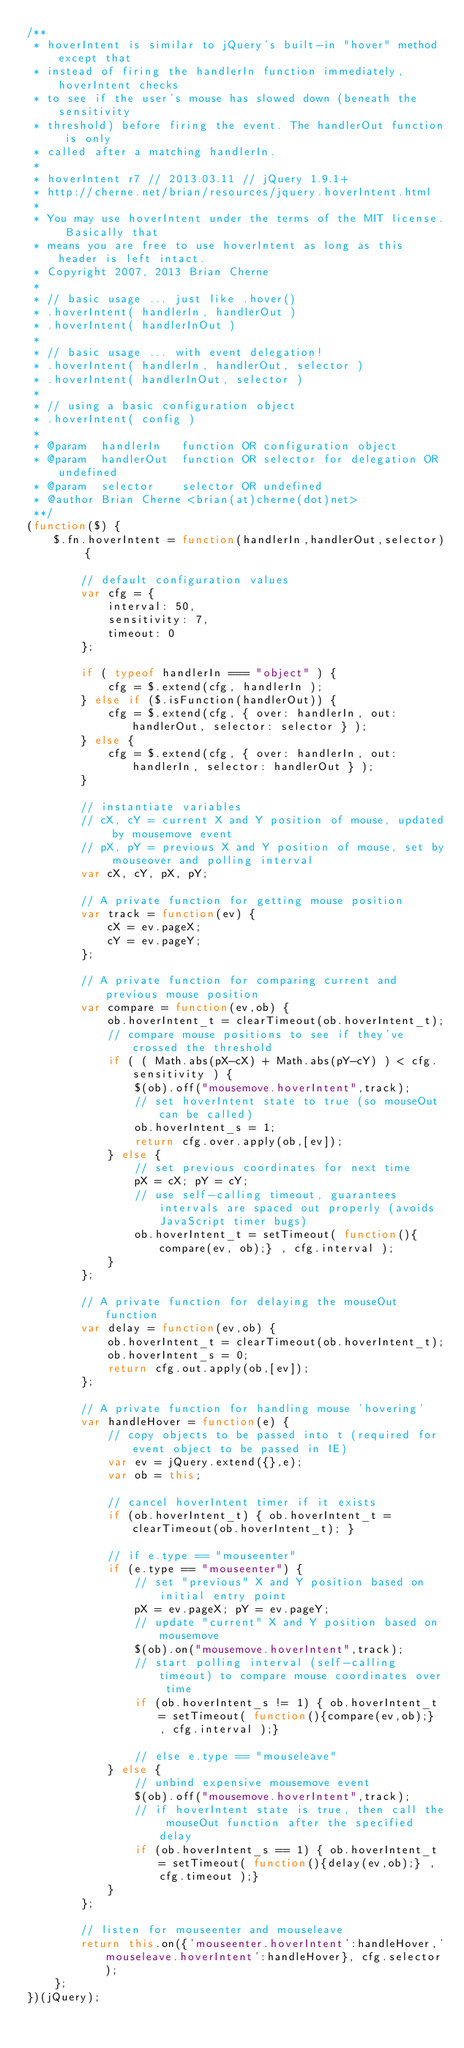<code> <loc_0><loc_0><loc_500><loc_500><_JavaScript_>/**
 * hoverIntent is similar to jQuery's built-in "hover" method except that
 * instead of firing the handlerIn function immediately, hoverIntent checks
 * to see if the user's mouse has slowed down (beneath the sensitivity
 * threshold) before firing the event. The handlerOut function is only
 * called after a matching handlerIn.
 *
 * hoverIntent r7 // 2013.03.11 // jQuery 1.9.1+
 * http://cherne.net/brian/resources/jquery.hoverIntent.html
 *
 * You may use hoverIntent under the terms of the MIT license. Basically that
 * means you are free to use hoverIntent as long as this header is left intact.
 * Copyright 2007, 2013 Brian Cherne
 *
 * // basic usage ... just like .hover()
 * .hoverIntent( handlerIn, handlerOut )
 * .hoverIntent( handlerInOut )
 *
 * // basic usage ... with event delegation!
 * .hoverIntent( handlerIn, handlerOut, selector )
 * .hoverIntent( handlerInOut, selector )
 *
 * // using a basic configuration object
 * .hoverIntent( config )
 *
 * @param  handlerIn   function OR configuration object
 * @param  handlerOut  function OR selector for delegation OR undefined
 * @param  selector    selector OR undefined
 * @author Brian Cherne <brian(at)cherne(dot)net>
 **/
(function($) {
    $.fn.hoverIntent = function(handlerIn,handlerOut,selector) {

        // default configuration values
        var cfg = {
            interval: 50,
            sensitivity: 7,
            timeout: 0
        };

        if ( typeof handlerIn === "object" ) {
            cfg = $.extend(cfg, handlerIn );
        } else if ($.isFunction(handlerOut)) {
            cfg = $.extend(cfg, { over: handlerIn, out: handlerOut, selector: selector } );
        } else {
            cfg = $.extend(cfg, { over: handlerIn, out: handlerIn, selector: handlerOut } );
        }

        // instantiate variables
        // cX, cY = current X and Y position of mouse, updated by mousemove event
        // pX, pY = previous X and Y position of mouse, set by mouseover and polling interval
        var cX, cY, pX, pY;

        // A private function for getting mouse position
        var track = function(ev) {
            cX = ev.pageX;
            cY = ev.pageY;
        };

        // A private function for comparing current and previous mouse position
        var compare = function(ev,ob) {
            ob.hoverIntent_t = clearTimeout(ob.hoverIntent_t);
            // compare mouse positions to see if they've crossed the threshold
            if ( ( Math.abs(pX-cX) + Math.abs(pY-cY) ) < cfg.sensitivity ) {
                $(ob).off("mousemove.hoverIntent",track);
                // set hoverIntent state to true (so mouseOut can be called)
                ob.hoverIntent_s = 1;
                return cfg.over.apply(ob,[ev]);
            } else {
                // set previous coordinates for next time
                pX = cX; pY = cY;
                // use self-calling timeout, guarantees intervals are spaced out properly (avoids JavaScript timer bugs)
                ob.hoverIntent_t = setTimeout( function(){compare(ev, ob);} , cfg.interval );
            }
        };

        // A private function for delaying the mouseOut function
        var delay = function(ev,ob) {
            ob.hoverIntent_t = clearTimeout(ob.hoverIntent_t);
            ob.hoverIntent_s = 0;
            return cfg.out.apply(ob,[ev]);
        };

        // A private function for handling mouse 'hovering'
        var handleHover = function(e) {
            // copy objects to be passed into t (required for event object to be passed in IE)
            var ev = jQuery.extend({},e);
            var ob = this;

            // cancel hoverIntent timer if it exists
            if (ob.hoverIntent_t) { ob.hoverIntent_t = clearTimeout(ob.hoverIntent_t); }

            // if e.type == "mouseenter"
            if (e.type == "mouseenter") {
                // set "previous" X and Y position based on initial entry point
                pX = ev.pageX; pY = ev.pageY;
                // update "current" X and Y position based on mousemove
                $(ob).on("mousemove.hoverIntent",track);
                // start polling interval (self-calling timeout) to compare mouse coordinates over time
                if (ob.hoverIntent_s != 1) { ob.hoverIntent_t = setTimeout( function(){compare(ev,ob);} , cfg.interval );}

                // else e.type == "mouseleave"
            } else {
                // unbind expensive mousemove event
                $(ob).off("mousemove.hoverIntent",track);
                // if hoverIntent state is true, then call the mouseOut function after the specified delay
                if (ob.hoverIntent_s == 1) { ob.hoverIntent_t = setTimeout( function(){delay(ev,ob);} , cfg.timeout );}
            }
        };

        // listen for mouseenter and mouseleave
        return this.on({'mouseenter.hoverIntent':handleHover,'mouseleave.hoverIntent':handleHover}, cfg.selector);
    };
})(jQuery);</code> 